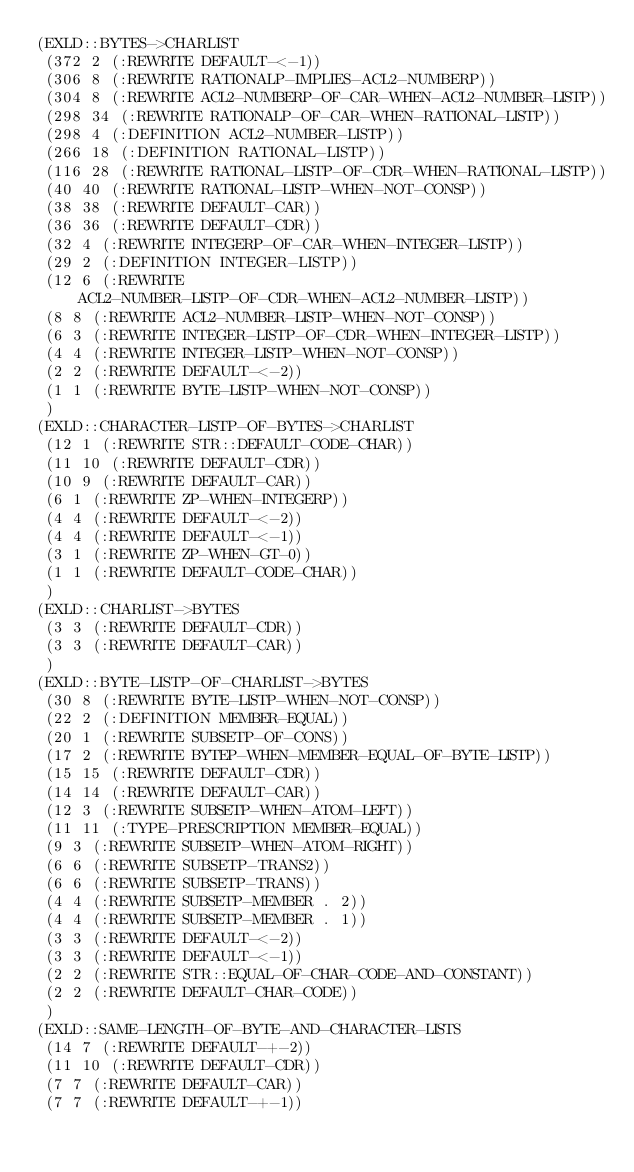<code> <loc_0><loc_0><loc_500><loc_500><_Lisp_>(EXLD::BYTES->CHARLIST
 (372 2 (:REWRITE DEFAULT-<-1))
 (306 8 (:REWRITE RATIONALP-IMPLIES-ACL2-NUMBERP))
 (304 8 (:REWRITE ACL2-NUMBERP-OF-CAR-WHEN-ACL2-NUMBER-LISTP))
 (298 34 (:REWRITE RATIONALP-OF-CAR-WHEN-RATIONAL-LISTP))
 (298 4 (:DEFINITION ACL2-NUMBER-LISTP))
 (266 18 (:DEFINITION RATIONAL-LISTP))
 (116 28 (:REWRITE RATIONAL-LISTP-OF-CDR-WHEN-RATIONAL-LISTP))
 (40 40 (:REWRITE RATIONAL-LISTP-WHEN-NOT-CONSP))
 (38 38 (:REWRITE DEFAULT-CAR))
 (36 36 (:REWRITE DEFAULT-CDR))
 (32 4 (:REWRITE INTEGERP-OF-CAR-WHEN-INTEGER-LISTP))
 (29 2 (:DEFINITION INTEGER-LISTP))
 (12 6 (:REWRITE ACL2-NUMBER-LISTP-OF-CDR-WHEN-ACL2-NUMBER-LISTP))
 (8 8 (:REWRITE ACL2-NUMBER-LISTP-WHEN-NOT-CONSP))
 (6 3 (:REWRITE INTEGER-LISTP-OF-CDR-WHEN-INTEGER-LISTP))
 (4 4 (:REWRITE INTEGER-LISTP-WHEN-NOT-CONSP))
 (2 2 (:REWRITE DEFAULT-<-2))
 (1 1 (:REWRITE BYTE-LISTP-WHEN-NOT-CONSP))
 )
(EXLD::CHARACTER-LISTP-OF-BYTES->CHARLIST
 (12 1 (:REWRITE STR::DEFAULT-CODE-CHAR))
 (11 10 (:REWRITE DEFAULT-CDR))
 (10 9 (:REWRITE DEFAULT-CAR))
 (6 1 (:REWRITE ZP-WHEN-INTEGERP))
 (4 4 (:REWRITE DEFAULT-<-2))
 (4 4 (:REWRITE DEFAULT-<-1))
 (3 1 (:REWRITE ZP-WHEN-GT-0))
 (1 1 (:REWRITE DEFAULT-CODE-CHAR))
 )
(EXLD::CHARLIST->BYTES
 (3 3 (:REWRITE DEFAULT-CDR))
 (3 3 (:REWRITE DEFAULT-CAR))
 )
(EXLD::BYTE-LISTP-OF-CHARLIST->BYTES
 (30 8 (:REWRITE BYTE-LISTP-WHEN-NOT-CONSP))
 (22 2 (:DEFINITION MEMBER-EQUAL))
 (20 1 (:REWRITE SUBSETP-OF-CONS))
 (17 2 (:REWRITE BYTEP-WHEN-MEMBER-EQUAL-OF-BYTE-LISTP))
 (15 15 (:REWRITE DEFAULT-CDR))
 (14 14 (:REWRITE DEFAULT-CAR))
 (12 3 (:REWRITE SUBSETP-WHEN-ATOM-LEFT))
 (11 11 (:TYPE-PRESCRIPTION MEMBER-EQUAL))
 (9 3 (:REWRITE SUBSETP-WHEN-ATOM-RIGHT))
 (6 6 (:REWRITE SUBSETP-TRANS2))
 (6 6 (:REWRITE SUBSETP-TRANS))
 (4 4 (:REWRITE SUBSETP-MEMBER . 2))
 (4 4 (:REWRITE SUBSETP-MEMBER . 1))
 (3 3 (:REWRITE DEFAULT-<-2))
 (3 3 (:REWRITE DEFAULT-<-1))
 (2 2 (:REWRITE STR::EQUAL-OF-CHAR-CODE-AND-CONSTANT))
 (2 2 (:REWRITE DEFAULT-CHAR-CODE))
 )
(EXLD::SAME-LENGTH-OF-BYTE-AND-CHARACTER-LISTS
 (14 7 (:REWRITE DEFAULT-+-2))
 (11 10 (:REWRITE DEFAULT-CDR))
 (7 7 (:REWRITE DEFAULT-CAR))
 (7 7 (:REWRITE DEFAULT-+-1))</code> 